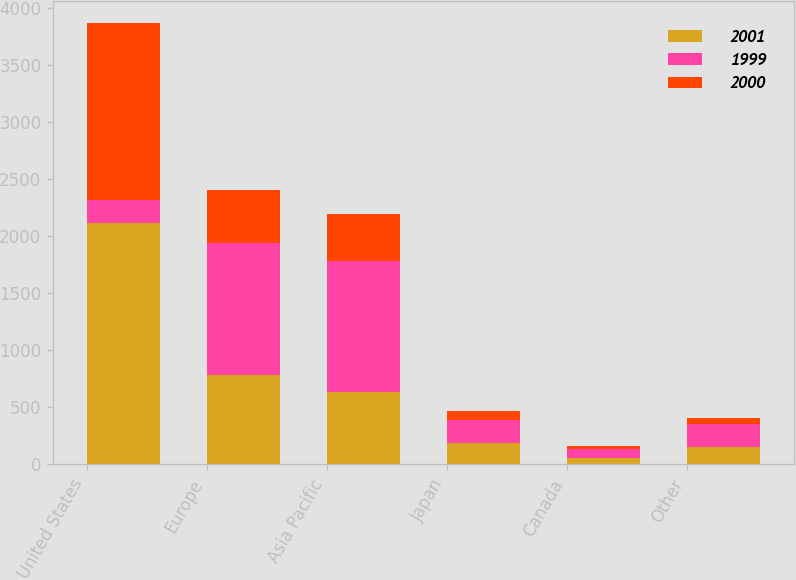<chart> <loc_0><loc_0><loc_500><loc_500><stacked_bar_chart><ecel><fcel>United States<fcel>Europe<fcel>Asia Pacific<fcel>Japan<fcel>Canada<fcel>Other<nl><fcel>2001<fcel>2116.8<fcel>780.9<fcel>637.9<fcel>188.8<fcel>57.1<fcel>154.4<nl><fcel>1999<fcel>203<fcel>1164.5<fcel>1144.8<fcel>203<fcel>77.3<fcel>202<nl><fcel>2000<fcel>1548.9<fcel>458<fcel>415.6<fcel>73.1<fcel>28.8<fcel>50.7<nl></chart> 